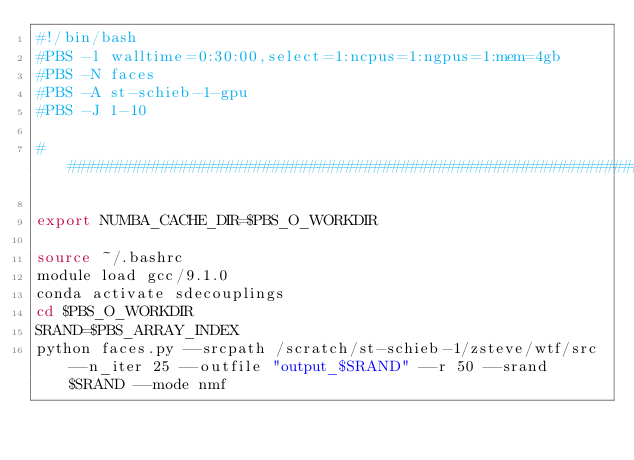Convert code to text. <code><loc_0><loc_0><loc_500><loc_500><_Bash_>#!/bin/bash
#PBS -l walltime=0:30:00,select=1:ncpus=1:ngpus=1:mem=4gb
#PBS -N faces
#PBS -A st-schieb-1-gpu
#PBS -J 1-10
 
################################################################################

export NUMBA_CACHE_DIR=$PBS_O_WORKDIR

source ~/.bashrc
module load gcc/9.1.0
conda activate sdecouplings
cd $PBS_O_WORKDIR
SRAND=$PBS_ARRAY_INDEX
python faces.py --srcpath /scratch/st-schieb-1/zsteve/wtf/src --n_iter 25 --outfile "output_$SRAND" --r 50 --srand $SRAND --mode nmf
</code> 